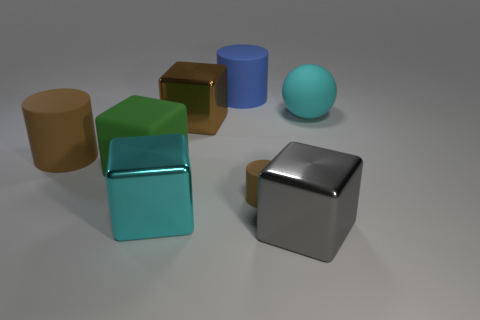Add 2 tiny gray metallic cylinders. How many objects exist? 10 Subtract all cylinders. How many objects are left? 5 Subtract all blue matte cylinders. Subtract all large cyan blocks. How many objects are left? 6 Add 7 large cyan rubber balls. How many large cyan rubber balls are left? 8 Add 3 cyan rubber balls. How many cyan rubber balls exist? 4 Subtract 1 blue cylinders. How many objects are left? 7 